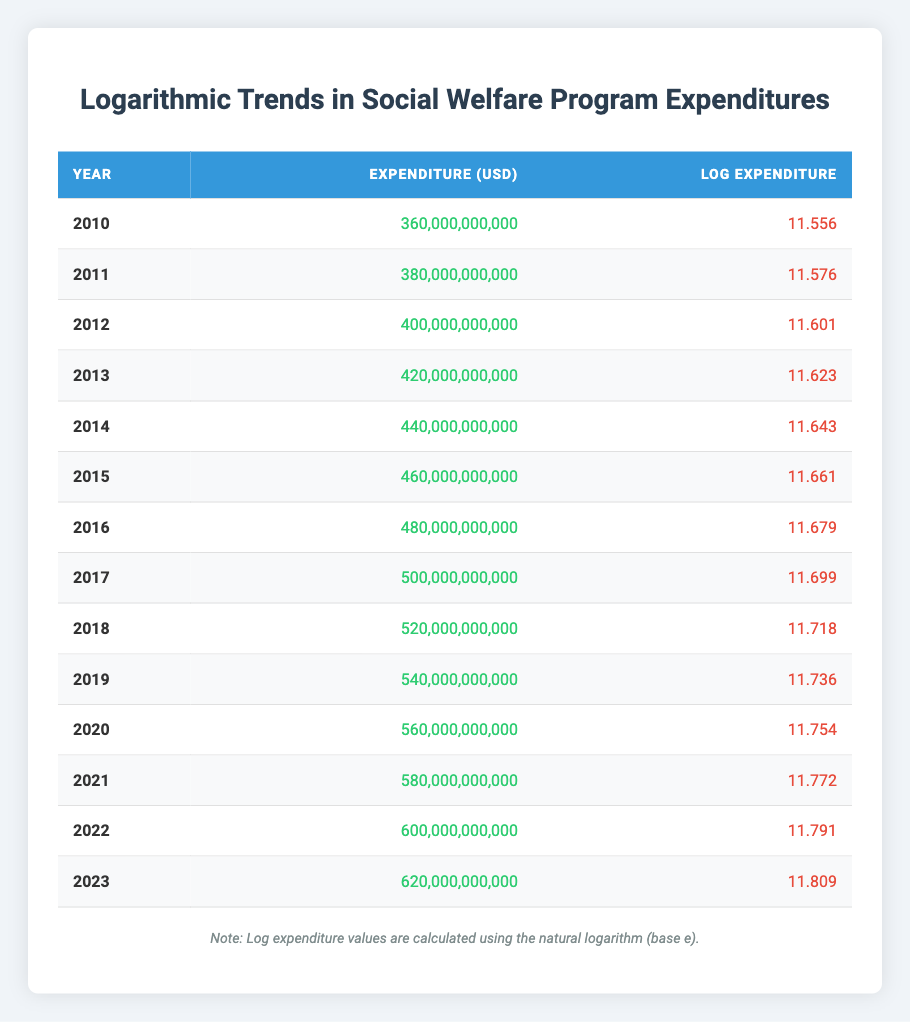What was the expenditure in 2015? The table lists the expenditure for 2015 under the "Expenditure (USD)" column, which shows 460,000,000,000.
Answer: 460,000,000,000 What is the log expenditure value for the year 2022? The log expenditure for 2022 can be found under the "Log Expenditure" column, which is 11.791.
Answer: 11.791 Which year had the highest expenditure? By examining the "Expenditure (USD)" column, the highest value is 620,000,000,000 for the year 2023.
Answer: 2023 What is the average expenditure from 2010 to 2023? To calculate the average, sum all expenditures from 2010 (360,000,000,000) to 2023 (620,000,000,000). The total is 8,080,000,000,000. Dividing by 14 years gives an average of 577,142,857,143.
Answer: 577,142,857,143 Did the expenditure increase every year from 2010 to 2023? By reviewing each year's expenditure, it consistently rises from 360,000,000,000 in 2010 to 620,000,000,000 in 2023 without any decline.
Answer: Yes What was the difference in log expenditure between 2010 and 2023? The log expenditure in 2010 is 11.556 and in 2023 it is 11.809. To find the difference, subtract the 2010 value from the 2023 value: 11.809 - 11.556 = 0.253.
Answer: 0.253 Which year saw an expenditure of exactly 500 billion USD? Reviewing the "Expenditure (USD)" column, the expenditure of 500,000,000,000 appears in the year 2017.
Answer: 2017 How many years had expenditures greater than 500 billion USD? By counting from the table, the years with expenditures greater than 500 billion USD are 2017, 2018, 2019, 2020, 2021, 2022, and 2023, totaling 7 years.
Answer: 7 What is the trend in log expenditure from 2010 to 2023? The log expenditure values increase each year, starting from 11.556 in 2010 and reaching 11.809 in 2023, indicating a steady rising trend over the years.
Answer: Rising trend 